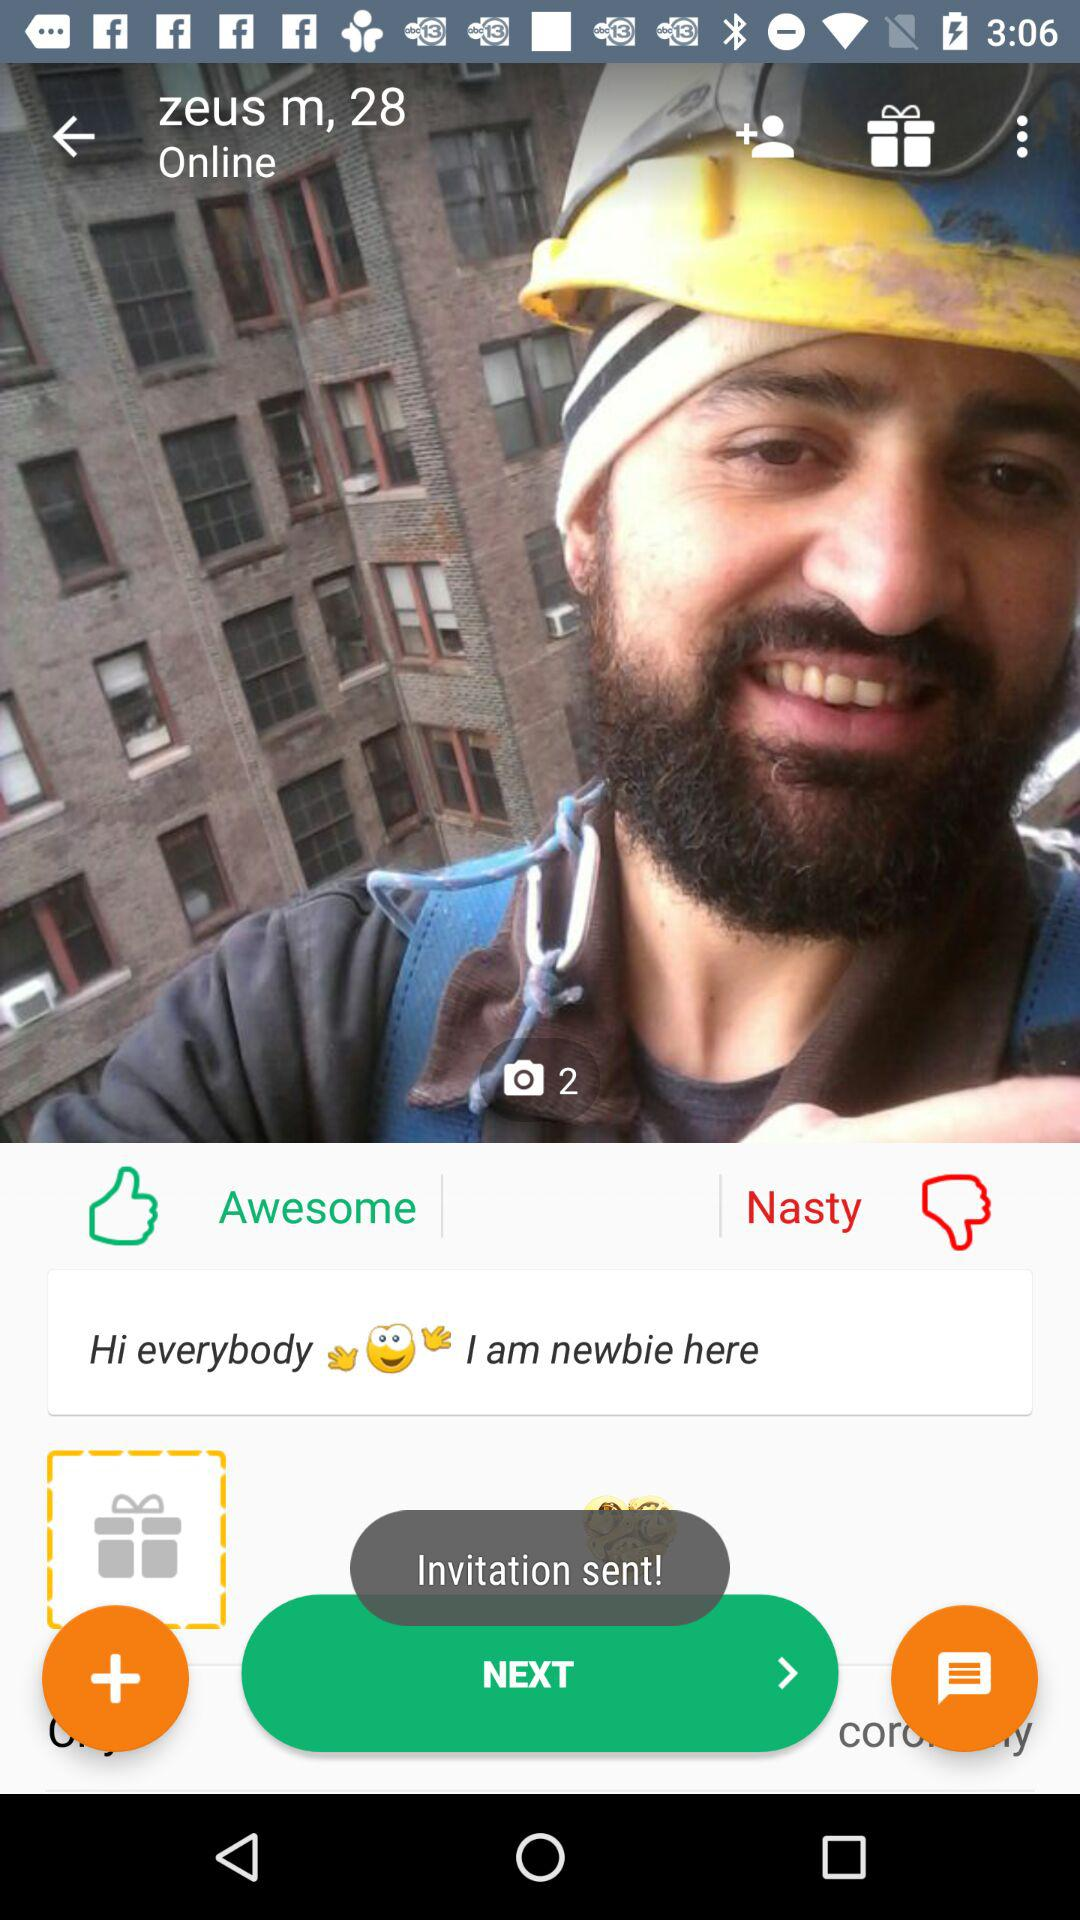What is the age of the user? The age of the user is 28 years. 